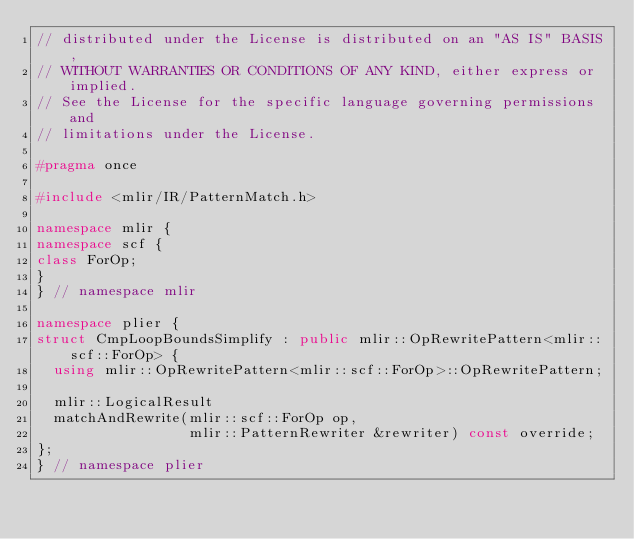Convert code to text. <code><loc_0><loc_0><loc_500><loc_500><_C++_>// distributed under the License is distributed on an "AS IS" BASIS,
// WITHOUT WARRANTIES OR CONDITIONS OF ANY KIND, either express or implied.
// See the License for the specific language governing permissions and
// limitations under the License.

#pragma once

#include <mlir/IR/PatternMatch.h>

namespace mlir {
namespace scf {
class ForOp;
}
} // namespace mlir

namespace plier {
struct CmpLoopBoundsSimplify : public mlir::OpRewritePattern<mlir::scf::ForOp> {
  using mlir::OpRewritePattern<mlir::scf::ForOp>::OpRewritePattern;

  mlir::LogicalResult
  matchAndRewrite(mlir::scf::ForOp op,
                  mlir::PatternRewriter &rewriter) const override;
};
} // namespace plier
</code> 